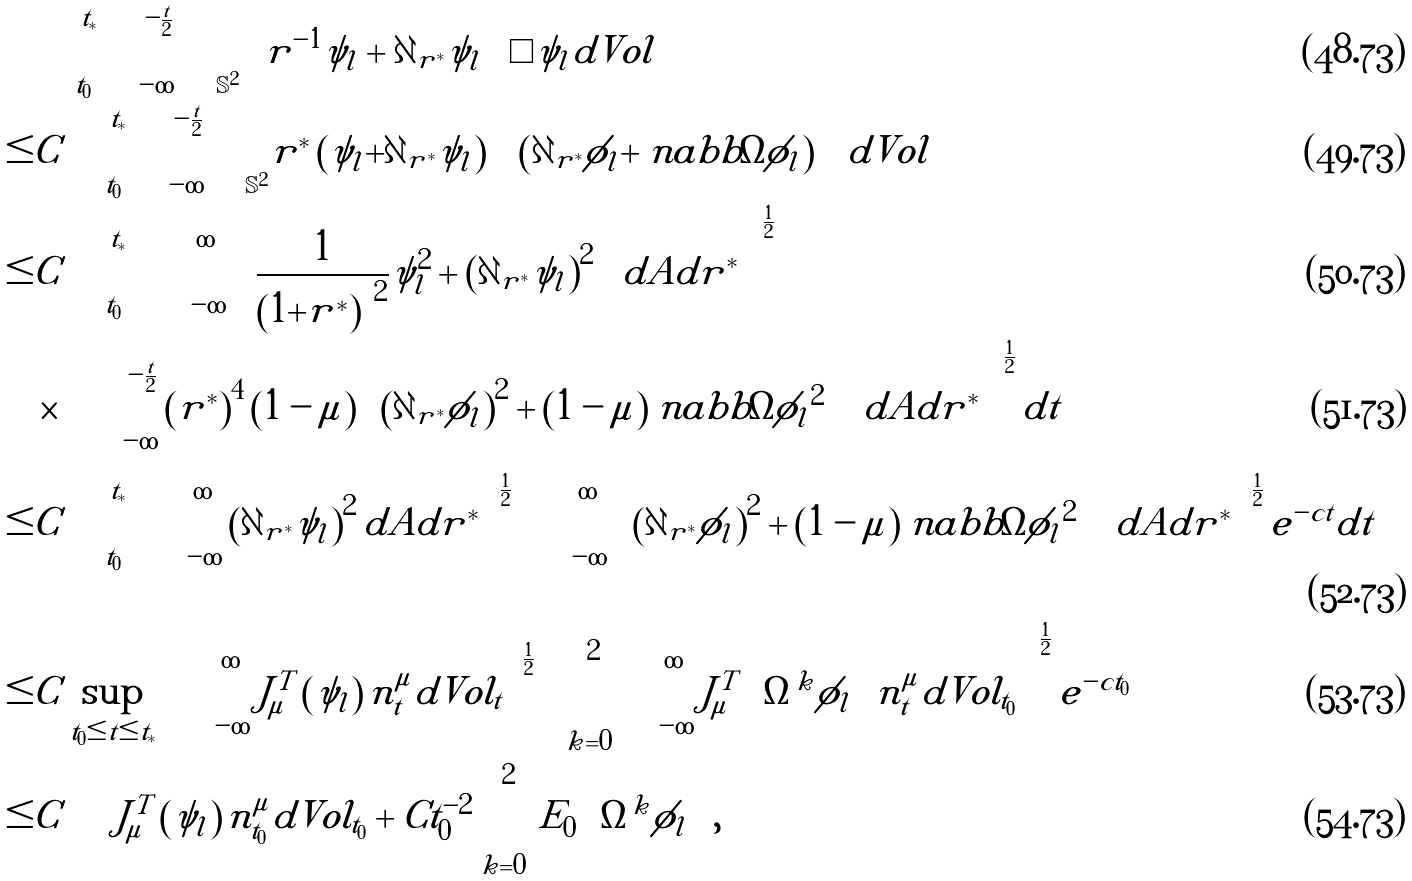<formula> <loc_0><loc_0><loc_500><loc_500>& \int _ { t _ { 0 } } ^ { t _ { * } } \int _ { - \infty } ^ { - \frac { t } { 2 } } \int _ { \mathbb { S } ^ { 2 } } | \left ( r ^ { - 1 } \psi _ { l } + \partial _ { r ^ { * } } \psi _ { l } \right ) \Box \psi _ { l } | d V o l \\ \leq & C \int _ { t _ { 0 } } ^ { t _ { * } } \int _ { - \infty } ^ { - \frac { t } { 2 } } \int _ { \mathbb { S } ^ { 2 } } | r ^ { * } | \left ( | \psi _ { l } | + | \partial _ { r ^ { * } } \psi _ { l } | \right ) \left ( | \partial _ { r ^ { * } } \phi _ { l } | + | \ n a b b \Omega \phi _ { l } | \right ) d V o l \\ \leq & C \int _ { t _ { 0 } } ^ { t _ { * } } \left ( \int _ { - \infty } ^ { \infty } \left ( \frac { 1 } { \left ( 1 + | r ^ { * } | \right ) ^ { 2 } } \psi _ { l } ^ { 2 } + \left ( \partial _ { r ^ { * } } \psi _ { l } \right ) ^ { 2 } \right ) d A d r ^ { * } \right ) ^ { \frac { 1 } { 2 } } \\ & \times \left ( \int _ { - \infty } ^ { - \frac { t } { 2 } } \left ( r ^ { * } \right ) ^ { 4 } \left ( 1 - \mu \right ) \left ( \left ( \partial _ { r ^ { * } } \phi _ { l } \right ) ^ { 2 } + \left ( 1 - \mu \right ) | \ n a b b \Omega \phi _ { l } | ^ { 2 } \right ) d A d r ^ { * } \right ) ^ { \frac { 1 } { 2 } } d t \\ \leq & C \int _ { t _ { 0 } } ^ { t _ { * } } \left ( \int _ { - \infty } ^ { \infty } \left ( \partial _ { r ^ { * } } \psi _ { l } \right ) ^ { 2 } d A d r ^ { * } \right ) ^ { \frac { 1 } { 2 } } \left ( \int _ { - \infty } ^ { \infty } \left ( \left ( \partial _ { r ^ { * } } \phi _ { l } \right ) ^ { 2 } + \left ( 1 - \mu \right ) | \ n a b b \Omega \phi _ { l } | ^ { 2 } \right ) d A d r ^ { * } \right ) ^ { \frac { 1 } { 2 } } e ^ { - c t } d t \\ \leq & C \sup _ { t _ { 0 } \leq t \leq t _ { * } } \left ( \int _ { - \infty } ^ { \infty } J ^ { T } _ { \mu } \left ( \psi _ { l } \right ) n ^ { \mu } _ { t } d V o l _ { t } \right ) ^ { \frac { 1 } { 2 } } \left ( \sum _ { k = 0 } ^ { 2 } \int _ { - \infty } ^ { \infty } J ^ { T } _ { \mu } \left ( \Omega ^ { k } \phi _ { l } \right ) n ^ { \mu } _ { t } d V o l _ { t _ { 0 } } \right ) ^ { \frac { 1 } { 2 } } e ^ { - c t _ { 0 } } \\ \leq & C \int J ^ { T } _ { \mu } \left ( \psi _ { l } \right ) n _ { t _ { 0 } } ^ { \mu } d V o l _ { t _ { 0 } } + C t _ { 0 } ^ { - 2 } \sum _ { k = 0 } ^ { 2 } E _ { 0 } \left ( \Omega ^ { k } \phi _ { l } \right ) ,</formula> 